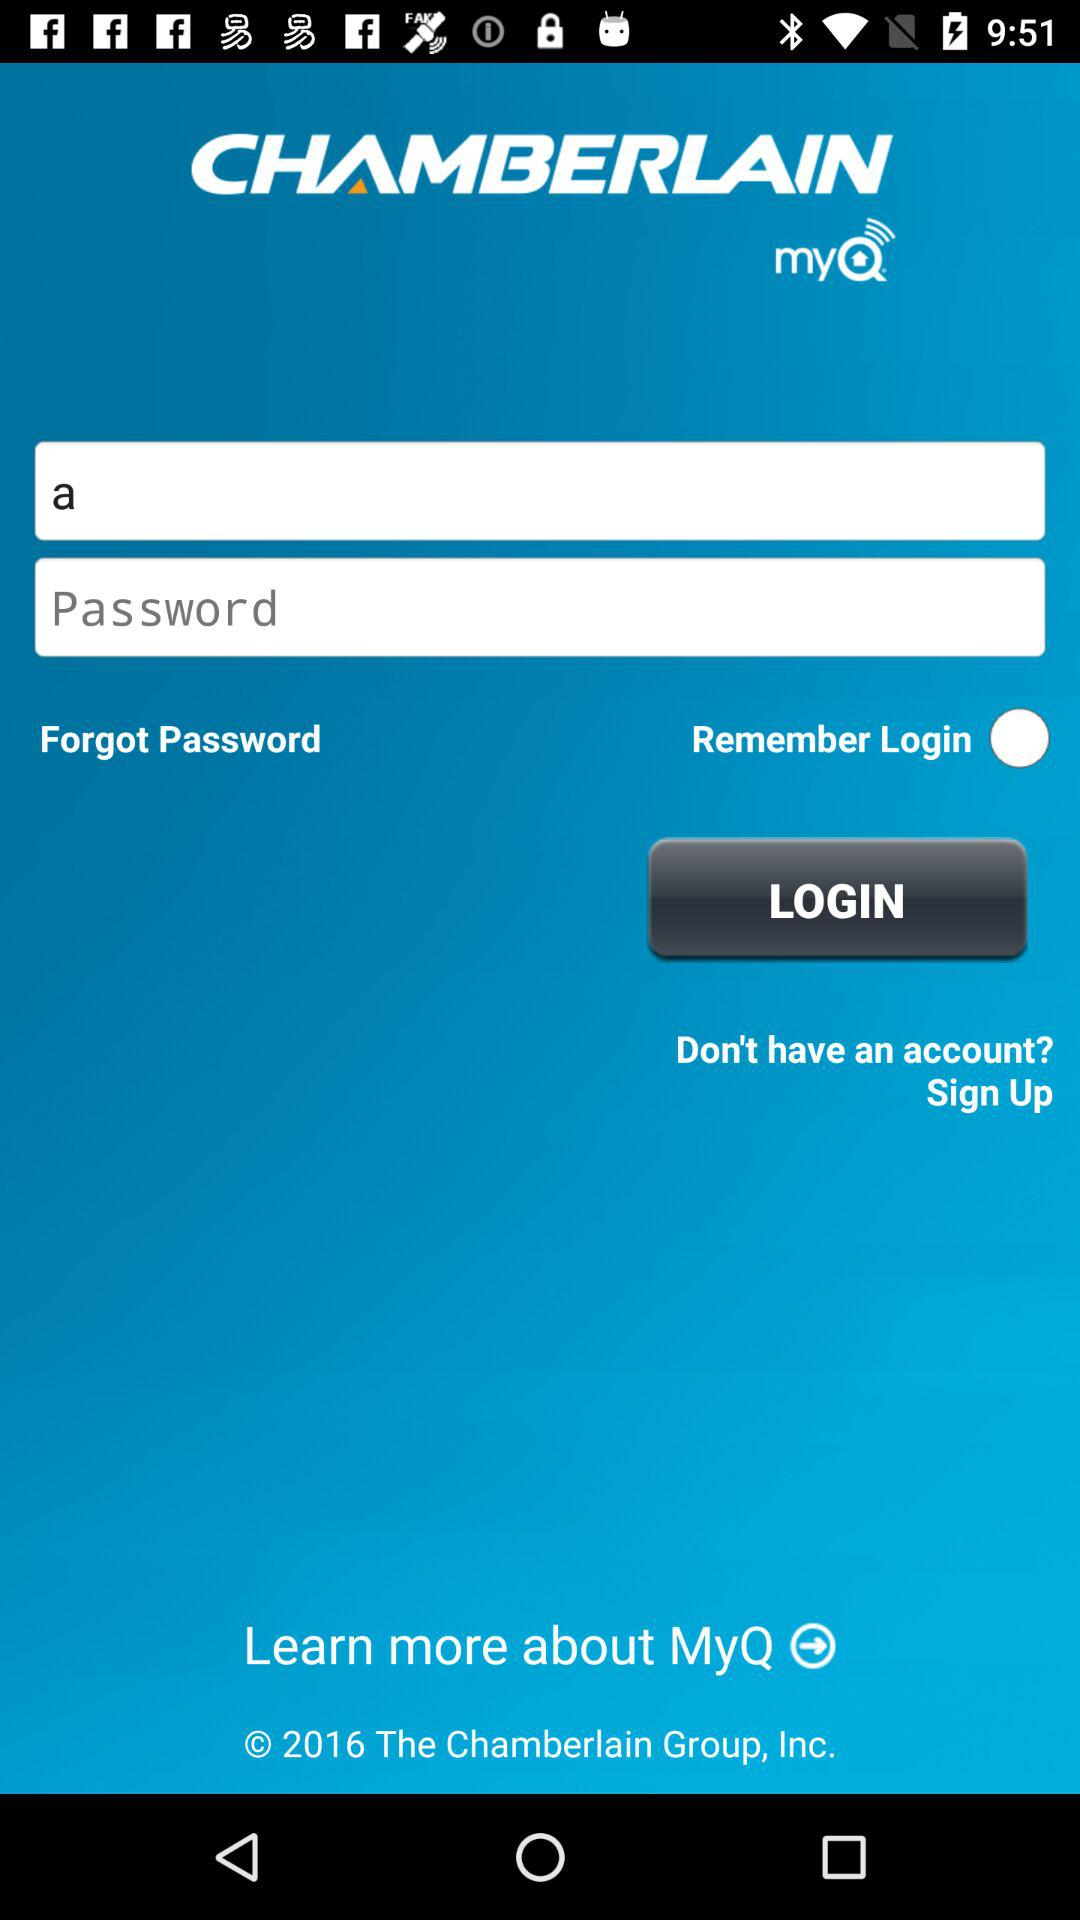What is the application name? The application name is "CHAMBERLAIN myQ". 